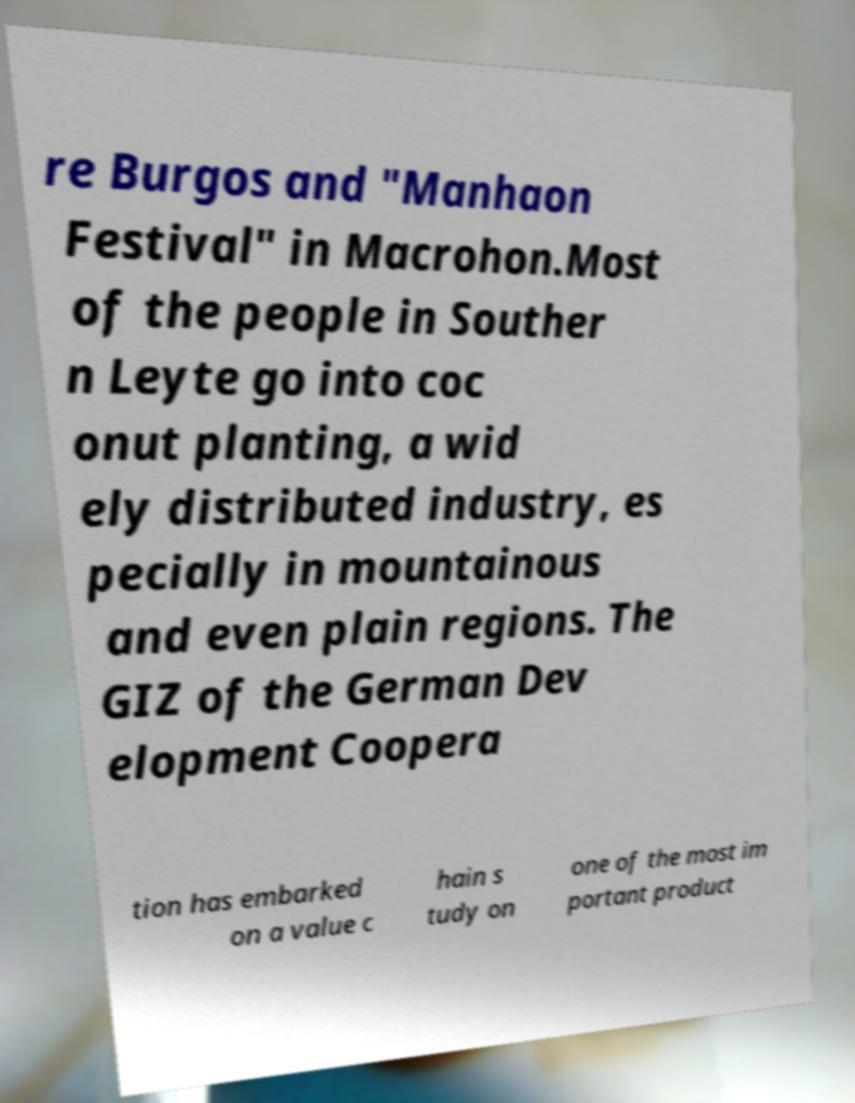Could you extract and type out the text from this image? re Burgos and "Manhaon Festival" in Macrohon.Most of the people in Souther n Leyte go into coc onut planting, a wid ely distributed industry, es pecially in mountainous and even plain regions. The GIZ of the German Dev elopment Coopera tion has embarked on a value c hain s tudy on one of the most im portant product 